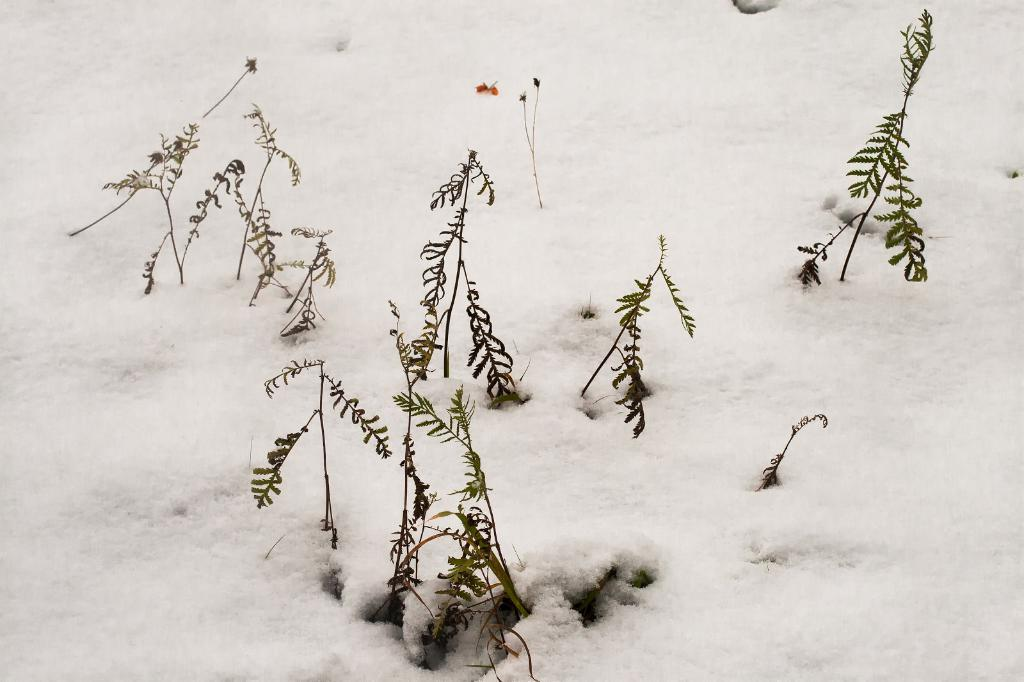What is covering the ground in the image? There is snow on the ground in the image. What type of vegetation can be seen in the image? There are plants visible in the image. What type of potato is being used as a guide for the plants in the image? There is no potato or indication of a guide for the plants in the image; it only shows snow on the ground and plants. 